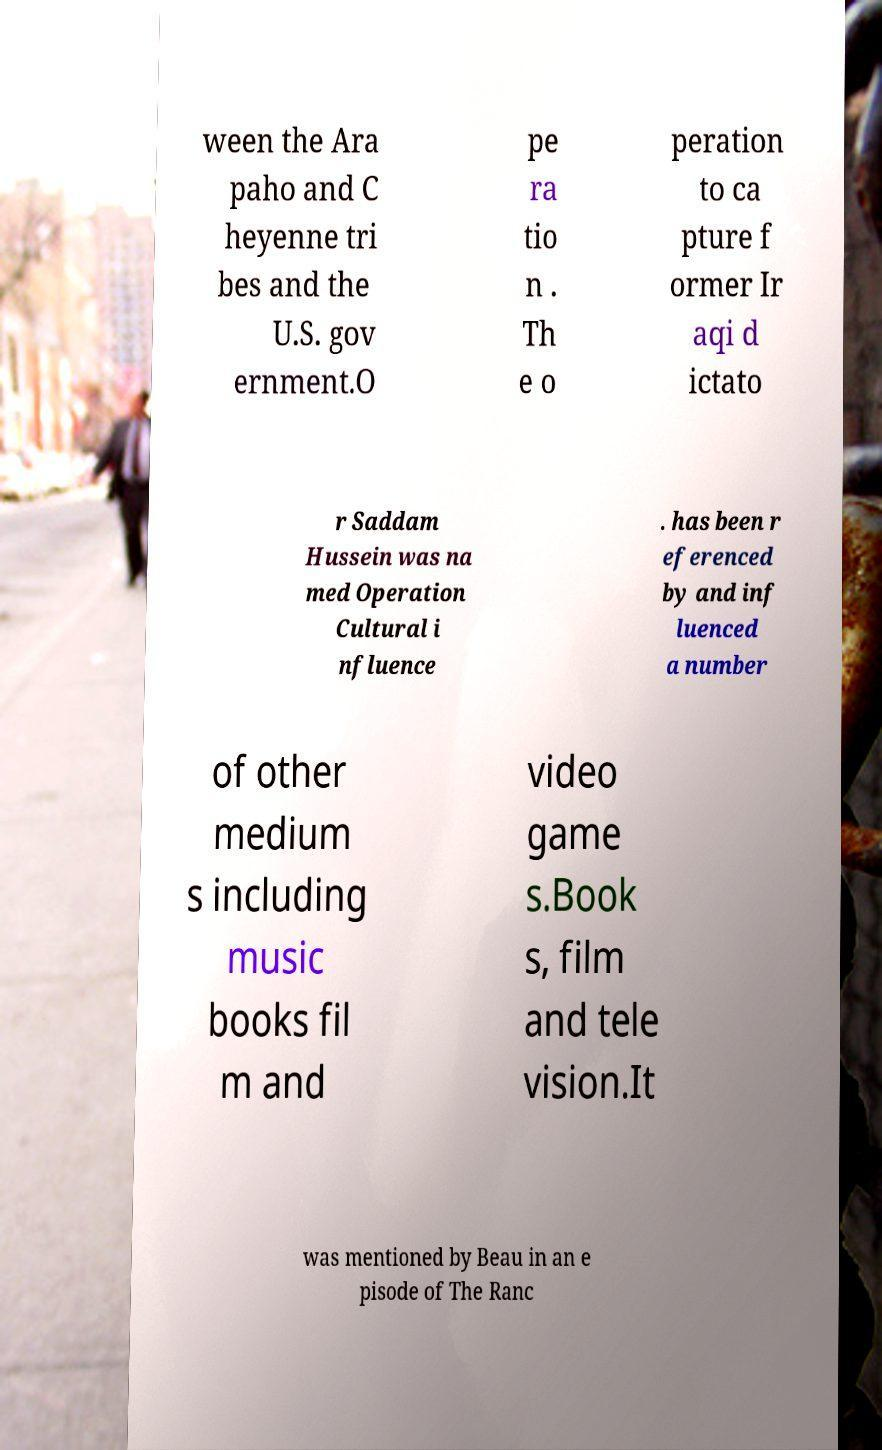There's text embedded in this image that I need extracted. Can you transcribe it verbatim? ween the Ara paho and C heyenne tri bes and the U.S. gov ernment.O pe ra tio n . Th e o peration to ca pture f ormer Ir aqi d ictato r Saddam Hussein was na med Operation Cultural i nfluence . has been r eferenced by and inf luenced a number of other medium s including music books fil m and video game s.Book s, film and tele vision.It was mentioned by Beau in an e pisode of The Ranc 